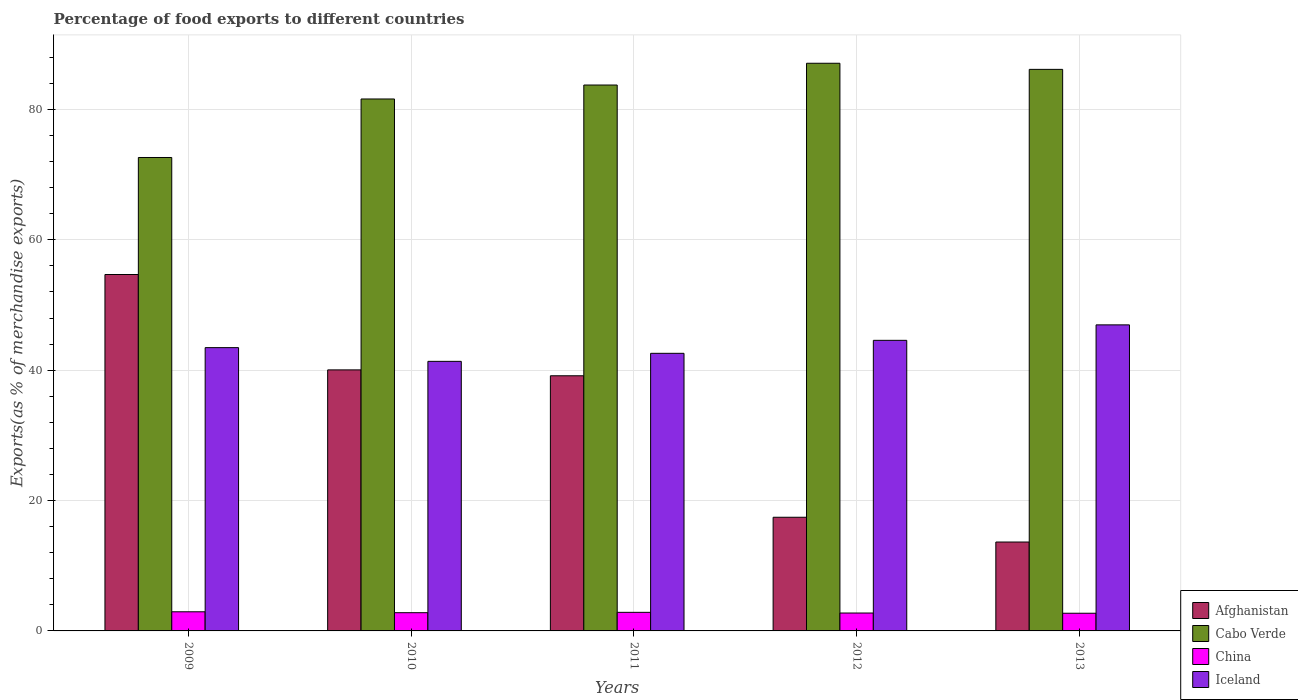How many different coloured bars are there?
Your answer should be very brief. 4. How many groups of bars are there?
Provide a short and direct response. 5. Are the number of bars per tick equal to the number of legend labels?
Ensure brevity in your answer.  Yes. How many bars are there on the 1st tick from the left?
Your answer should be compact. 4. How many bars are there on the 4th tick from the right?
Your answer should be very brief. 4. What is the label of the 3rd group of bars from the left?
Your answer should be compact. 2011. In how many cases, is the number of bars for a given year not equal to the number of legend labels?
Make the answer very short. 0. What is the percentage of exports to different countries in China in 2012?
Make the answer very short. 2.75. Across all years, what is the maximum percentage of exports to different countries in Cabo Verde?
Give a very brief answer. 87.09. Across all years, what is the minimum percentage of exports to different countries in Afghanistan?
Ensure brevity in your answer.  13.64. In which year was the percentage of exports to different countries in China minimum?
Provide a short and direct response. 2013. What is the total percentage of exports to different countries in China in the graph?
Keep it short and to the point. 14.04. What is the difference between the percentage of exports to different countries in Afghanistan in 2010 and that in 2012?
Your answer should be compact. 22.61. What is the difference between the percentage of exports to different countries in Iceland in 2012 and the percentage of exports to different countries in Afghanistan in 2013?
Offer a very short reply. 30.94. What is the average percentage of exports to different countries in Cabo Verde per year?
Your response must be concise. 82.25. In the year 2012, what is the difference between the percentage of exports to different countries in China and percentage of exports to different countries in Iceland?
Your answer should be compact. -41.83. In how many years, is the percentage of exports to different countries in Afghanistan greater than 40 %?
Offer a very short reply. 2. What is the ratio of the percentage of exports to different countries in Afghanistan in 2011 to that in 2012?
Your answer should be compact. 2.24. Is the difference between the percentage of exports to different countries in China in 2010 and 2011 greater than the difference between the percentage of exports to different countries in Iceland in 2010 and 2011?
Your answer should be very brief. Yes. What is the difference between the highest and the second highest percentage of exports to different countries in Cabo Verde?
Give a very brief answer. 0.94. What is the difference between the highest and the lowest percentage of exports to different countries in China?
Keep it short and to the point. 0.22. In how many years, is the percentage of exports to different countries in Cabo Verde greater than the average percentage of exports to different countries in Cabo Verde taken over all years?
Provide a short and direct response. 3. Is it the case that in every year, the sum of the percentage of exports to different countries in Cabo Verde and percentage of exports to different countries in Afghanistan is greater than the sum of percentage of exports to different countries in China and percentage of exports to different countries in Iceland?
Offer a terse response. Yes. What does the 3rd bar from the left in 2013 represents?
Offer a terse response. China. Is it the case that in every year, the sum of the percentage of exports to different countries in Cabo Verde and percentage of exports to different countries in Afghanistan is greater than the percentage of exports to different countries in Iceland?
Your answer should be very brief. Yes. How many bars are there?
Your answer should be very brief. 20. Are all the bars in the graph horizontal?
Ensure brevity in your answer.  No. How many years are there in the graph?
Give a very brief answer. 5. What is the difference between two consecutive major ticks on the Y-axis?
Your answer should be compact. 20. Are the values on the major ticks of Y-axis written in scientific E-notation?
Keep it short and to the point. No. Does the graph contain grids?
Keep it short and to the point. Yes. How are the legend labels stacked?
Provide a succinct answer. Vertical. What is the title of the graph?
Give a very brief answer. Percentage of food exports to different countries. What is the label or title of the X-axis?
Provide a short and direct response. Years. What is the label or title of the Y-axis?
Your answer should be compact. Exports(as % of merchandise exports). What is the Exports(as % of merchandise exports) of Afghanistan in 2009?
Offer a very short reply. 54.68. What is the Exports(as % of merchandise exports) in Cabo Verde in 2009?
Give a very brief answer. 72.63. What is the Exports(as % of merchandise exports) of China in 2009?
Your answer should be compact. 2.94. What is the Exports(as % of merchandise exports) in Iceland in 2009?
Make the answer very short. 43.46. What is the Exports(as % of merchandise exports) of Afghanistan in 2010?
Ensure brevity in your answer.  40.05. What is the Exports(as % of merchandise exports) of Cabo Verde in 2010?
Keep it short and to the point. 81.61. What is the Exports(as % of merchandise exports) of China in 2010?
Offer a very short reply. 2.8. What is the Exports(as % of merchandise exports) in Iceland in 2010?
Give a very brief answer. 41.36. What is the Exports(as % of merchandise exports) in Afghanistan in 2011?
Offer a very short reply. 39.15. What is the Exports(as % of merchandise exports) of Cabo Verde in 2011?
Your response must be concise. 83.75. What is the Exports(as % of merchandise exports) in China in 2011?
Your answer should be very brief. 2.85. What is the Exports(as % of merchandise exports) in Iceland in 2011?
Your answer should be compact. 42.59. What is the Exports(as % of merchandise exports) of Afghanistan in 2012?
Your response must be concise. 17.44. What is the Exports(as % of merchandise exports) of Cabo Verde in 2012?
Keep it short and to the point. 87.09. What is the Exports(as % of merchandise exports) in China in 2012?
Make the answer very short. 2.75. What is the Exports(as % of merchandise exports) of Iceland in 2012?
Offer a very short reply. 44.58. What is the Exports(as % of merchandise exports) in Afghanistan in 2013?
Keep it short and to the point. 13.64. What is the Exports(as % of merchandise exports) in Cabo Verde in 2013?
Provide a short and direct response. 86.15. What is the Exports(as % of merchandise exports) in China in 2013?
Make the answer very short. 2.71. What is the Exports(as % of merchandise exports) of Iceland in 2013?
Make the answer very short. 46.95. Across all years, what is the maximum Exports(as % of merchandise exports) in Afghanistan?
Your response must be concise. 54.68. Across all years, what is the maximum Exports(as % of merchandise exports) of Cabo Verde?
Your answer should be very brief. 87.09. Across all years, what is the maximum Exports(as % of merchandise exports) in China?
Your answer should be compact. 2.94. Across all years, what is the maximum Exports(as % of merchandise exports) of Iceland?
Ensure brevity in your answer.  46.95. Across all years, what is the minimum Exports(as % of merchandise exports) in Afghanistan?
Your answer should be compact. 13.64. Across all years, what is the minimum Exports(as % of merchandise exports) of Cabo Verde?
Ensure brevity in your answer.  72.63. Across all years, what is the minimum Exports(as % of merchandise exports) of China?
Keep it short and to the point. 2.71. Across all years, what is the minimum Exports(as % of merchandise exports) in Iceland?
Offer a very short reply. 41.36. What is the total Exports(as % of merchandise exports) in Afghanistan in the graph?
Make the answer very short. 164.95. What is the total Exports(as % of merchandise exports) of Cabo Verde in the graph?
Your answer should be compact. 411.24. What is the total Exports(as % of merchandise exports) in China in the graph?
Your answer should be very brief. 14.04. What is the total Exports(as % of merchandise exports) of Iceland in the graph?
Offer a very short reply. 218.94. What is the difference between the Exports(as % of merchandise exports) of Afghanistan in 2009 and that in 2010?
Offer a terse response. 14.63. What is the difference between the Exports(as % of merchandise exports) in Cabo Verde in 2009 and that in 2010?
Provide a succinct answer. -8.98. What is the difference between the Exports(as % of merchandise exports) in China in 2009 and that in 2010?
Provide a succinct answer. 0.14. What is the difference between the Exports(as % of merchandise exports) in Iceland in 2009 and that in 2010?
Provide a succinct answer. 2.1. What is the difference between the Exports(as % of merchandise exports) in Afghanistan in 2009 and that in 2011?
Offer a terse response. 15.53. What is the difference between the Exports(as % of merchandise exports) in Cabo Verde in 2009 and that in 2011?
Offer a terse response. -11.12. What is the difference between the Exports(as % of merchandise exports) in China in 2009 and that in 2011?
Ensure brevity in your answer.  0.08. What is the difference between the Exports(as % of merchandise exports) in Iceland in 2009 and that in 2011?
Your answer should be very brief. 0.87. What is the difference between the Exports(as % of merchandise exports) of Afghanistan in 2009 and that in 2012?
Offer a very short reply. 37.24. What is the difference between the Exports(as % of merchandise exports) of Cabo Verde in 2009 and that in 2012?
Provide a succinct answer. -14.46. What is the difference between the Exports(as % of merchandise exports) in China in 2009 and that in 2012?
Keep it short and to the point. 0.19. What is the difference between the Exports(as % of merchandise exports) of Iceland in 2009 and that in 2012?
Provide a short and direct response. -1.12. What is the difference between the Exports(as % of merchandise exports) of Afghanistan in 2009 and that in 2013?
Your answer should be compact. 41.04. What is the difference between the Exports(as % of merchandise exports) of Cabo Verde in 2009 and that in 2013?
Ensure brevity in your answer.  -13.52. What is the difference between the Exports(as % of merchandise exports) of China in 2009 and that in 2013?
Your response must be concise. 0.22. What is the difference between the Exports(as % of merchandise exports) of Iceland in 2009 and that in 2013?
Keep it short and to the point. -3.49. What is the difference between the Exports(as % of merchandise exports) of Afghanistan in 2010 and that in 2011?
Your response must be concise. 0.9. What is the difference between the Exports(as % of merchandise exports) in Cabo Verde in 2010 and that in 2011?
Provide a succinct answer. -2.14. What is the difference between the Exports(as % of merchandise exports) of China in 2010 and that in 2011?
Give a very brief answer. -0.06. What is the difference between the Exports(as % of merchandise exports) of Iceland in 2010 and that in 2011?
Keep it short and to the point. -1.23. What is the difference between the Exports(as % of merchandise exports) in Afghanistan in 2010 and that in 2012?
Offer a terse response. 22.61. What is the difference between the Exports(as % of merchandise exports) in Cabo Verde in 2010 and that in 2012?
Make the answer very short. -5.48. What is the difference between the Exports(as % of merchandise exports) of China in 2010 and that in 2012?
Provide a succinct answer. 0.05. What is the difference between the Exports(as % of merchandise exports) of Iceland in 2010 and that in 2012?
Keep it short and to the point. -3.22. What is the difference between the Exports(as % of merchandise exports) of Afghanistan in 2010 and that in 2013?
Make the answer very short. 26.41. What is the difference between the Exports(as % of merchandise exports) of Cabo Verde in 2010 and that in 2013?
Ensure brevity in your answer.  -4.54. What is the difference between the Exports(as % of merchandise exports) in China in 2010 and that in 2013?
Your answer should be very brief. 0.08. What is the difference between the Exports(as % of merchandise exports) in Iceland in 2010 and that in 2013?
Provide a succinct answer. -5.6. What is the difference between the Exports(as % of merchandise exports) in Afghanistan in 2011 and that in 2012?
Give a very brief answer. 21.71. What is the difference between the Exports(as % of merchandise exports) in Cabo Verde in 2011 and that in 2012?
Give a very brief answer. -3.34. What is the difference between the Exports(as % of merchandise exports) of China in 2011 and that in 2012?
Ensure brevity in your answer.  0.1. What is the difference between the Exports(as % of merchandise exports) of Iceland in 2011 and that in 2012?
Your answer should be very brief. -1.99. What is the difference between the Exports(as % of merchandise exports) in Afghanistan in 2011 and that in 2013?
Your answer should be compact. 25.51. What is the difference between the Exports(as % of merchandise exports) in Cabo Verde in 2011 and that in 2013?
Provide a short and direct response. -2.4. What is the difference between the Exports(as % of merchandise exports) in China in 2011 and that in 2013?
Keep it short and to the point. 0.14. What is the difference between the Exports(as % of merchandise exports) of Iceland in 2011 and that in 2013?
Keep it short and to the point. -4.37. What is the difference between the Exports(as % of merchandise exports) of Afghanistan in 2012 and that in 2013?
Offer a very short reply. 3.8. What is the difference between the Exports(as % of merchandise exports) of Cabo Verde in 2012 and that in 2013?
Provide a succinct answer. 0.94. What is the difference between the Exports(as % of merchandise exports) in China in 2012 and that in 2013?
Offer a terse response. 0.03. What is the difference between the Exports(as % of merchandise exports) in Iceland in 2012 and that in 2013?
Your response must be concise. -2.37. What is the difference between the Exports(as % of merchandise exports) of Afghanistan in 2009 and the Exports(as % of merchandise exports) of Cabo Verde in 2010?
Provide a short and direct response. -26.93. What is the difference between the Exports(as % of merchandise exports) of Afghanistan in 2009 and the Exports(as % of merchandise exports) of China in 2010?
Your answer should be very brief. 51.88. What is the difference between the Exports(as % of merchandise exports) of Afghanistan in 2009 and the Exports(as % of merchandise exports) of Iceland in 2010?
Provide a succinct answer. 13.32. What is the difference between the Exports(as % of merchandise exports) of Cabo Verde in 2009 and the Exports(as % of merchandise exports) of China in 2010?
Ensure brevity in your answer.  69.84. What is the difference between the Exports(as % of merchandise exports) of Cabo Verde in 2009 and the Exports(as % of merchandise exports) of Iceland in 2010?
Give a very brief answer. 31.28. What is the difference between the Exports(as % of merchandise exports) in China in 2009 and the Exports(as % of merchandise exports) in Iceland in 2010?
Provide a succinct answer. -38.42. What is the difference between the Exports(as % of merchandise exports) in Afghanistan in 2009 and the Exports(as % of merchandise exports) in Cabo Verde in 2011?
Offer a terse response. -29.07. What is the difference between the Exports(as % of merchandise exports) in Afghanistan in 2009 and the Exports(as % of merchandise exports) in China in 2011?
Your answer should be compact. 51.83. What is the difference between the Exports(as % of merchandise exports) in Afghanistan in 2009 and the Exports(as % of merchandise exports) in Iceland in 2011?
Your answer should be very brief. 12.09. What is the difference between the Exports(as % of merchandise exports) of Cabo Verde in 2009 and the Exports(as % of merchandise exports) of China in 2011?
Your response must be concise. 69.78. What is the difference between the Exports(as % of merchandise exports) of Cabo Verde in 2009 and the Exports(as % of merchandise exports) of Iceland in 2011?
Your response must be concise. 30.04. What is the difference between the Exports(as % of merchandise exports) of China in 2009 and the Exports(as % of merchandise exports) of Iceland in 2011?
Give a very brief answer. -39.65. What is the difference between the Exports(as % of merchandise exports) in Afghanistan in 2009 and the Exports(as % of merchandise exports) in Cabo Verde in 2012?
Your answer should be very brief. -32.41. What is the difference between the Exports(as % of merchandise exports) of Afghanistan in 2009 and the Exports(as % of merchandise exports) of China in 2012?
Your response must be concise. 51.93. What is the difference between the Exports(as % of merchandise exports) in Afghanistan in 2009 and the Exports(as % of merchandise exports) in Iceland in 2012?
Give a very brief answer. 10.1. What is the difference between the Exports(as % of merchandise exports) in Cabo Verde in 2009 and the Exports(as % of merchandise exports) in China in 2012?
Provide a succinct answer. 69.89. What is the difference between the Exports(as % of merchandise exports) of Cabo Verde in 2009 and the Exports(as % of merchandise exports) of Iceland in 2012?
Make the answer very short. 28.05. What is the difference between the Exports(as % of merchandise exports) in China in 2009 and the Exports(as % of merchandise exports) in Iceland in 2012?
Provide a succinct answer. -41.65. What is the difference between the Exports(as % of merchandise exports) of Afghanistan in 2009 and the Exports(as % of merchandise exports) of Cabo Verde in 2013?
Your answer should be very brief. -31.47. What is the difference between the Exports(as % of merchandise exports) of Afghanistan in 2009 and the Exports(as % of merchandise exports) of China in 2013?
Your response must be concise. 51.97. What is the difference between the Exports(as % of merchandise exports) of Afghanistan in 2009 and the Exports(as % of merchandise exports) of Iceland in 2013?
Provide a succinct answer. 7.73. What is the difference between the Exports(as % of merchandise exports) of Cabo Verde in 2009 and the Exports(as % of merchandise exports) of China in 2013?
Provide a succinct answer. 69.92. What is the difference between the Exports(as % of merchandise exports) of Cabo Verde in 2009 and the Exports(as % of merchandise exports) of Iceland in 2013?
Your response must be concise. 25.68. What is the difference between the Exports(as % of merchandise exports) of China in 2009 and the Exports(as % of merchandise exports) of Iceland in 2013?
Provide a short and direct response. -44.02. What is the difference between the Exports(as % of merchandise exports) in Afghanistan in 2010 and the Exports(as % of merchandise exports) in Cabo Verde in 2011?
Your response must be concise. -43.7. What is the difference between the Exports(as % of merchandise exports) of Afghanistan in 2010 and the Exports(as % of merchandise exports) of China in 2011?
Provide a succinct answer. 37.2. What is the difference between the Exports(as % of merchandise exports) of Afghanistan in 2010 and the Exports(as % of merchandise exports) of Iceland in 2011?
Provide a short and direct response. -2.54. What is the difference between the Exports(as % of merchandise exports) of Cabo Verde in 2010 and the Exports(as % of merchandise exports) of China in 2011?
Ensure brevity in your answer.  78.76. What is the difference between the Exports(as % of merchandise exports) in Cabo Verde in 2010 and the Exports(as % of merchandise exports) in Iceland in 2011?
Offer a very short reply. 39.02. What is the difference between the Exports(as % of merchandise exports) in China in 2010 and the Exports(as % of merchandise exports) in Iceland in 2011?
Your answer should be very brief. -39.79. What is the difference between the Exports(as % of merchandise exports) in Afghanistan in 2010 and the Exports(as % of merchandise exports) in Cabo Verde in 2012?
Make the answer very short. -47.04. What is the difference between the Exports(as % of merchandise exports) in Afghanistan in 2010 and the Exports(as % of merchandise exports) in China in 2012?
Make the answer very short. 37.3. What is the difference between the Exports(as % of merchandise exports) of Afghanistan in 2010 and the Exports(as % of merchandise exports) of Iceland in 2012?
Your answer should be compact. -4.53. What is the difference between the Exports(as % of merchandise exports) in Cabo Verde in 2010 and the Exports(as % of merchandise exports) in China in 2012?
Your response must be concise. 78.86. What is the difference between the Exports(as % of merchandise exports) of Cabo Verde in 2010 and the Exports(as % of merchandise exports) of Iceland in 2012?
Give a very brief answer. 37.03. What is the difference between the Exports(as % of merchandise exports) in China in 2010 and the Exports(as % of merchandise exports) in Iceland in 2012?
Provide a succinct answer. -41.79. What is the difference between the Exports(as % of merchandise exports) of Afghanistan in 2010 and the Exports(as % of merchandise exports) of Cabo Verde in 2013?
Keep it short and to the point. -46.11. What is the difference between the Exports(as % of merchandise exports) of Afghanistan in 2010 and the Exports(as % of merchandise exports) of China in 2013?
Provide a short and direct response. 37.33. What is the difference between the Exports(as % of merchandise exports) of Afghanistan in 2010 and the Exports(as % of merchandise exports) of Iceland in 2013?
Ensure brevity in your answer.  -6.91. What is the difference between the Exports(as % of merchandise exports) in Cabo Verde in 2010 and the Exports(as % of merchandise exports) in China in 2013?
Give a very brief answer. 78.9. What is the difference between the Exports(as % of merchandise exports) in Cabo Verde in 2010 and the Exports(as % of merchandise exports) in Iceland in 2013?
Provide a short and direct response. 34.65. What is the difference between the Exports(as % of merchandise exports) in China in 2010 and the Exports(as % of merchandise exports) in Iceland in 2013?
Your answer should be very brief. -44.16. What is the difference between the Exports(as % of merchandise exports) of Afghanistan in 2011 and the Exports(as % of merchandise exports) of Cabo Verde in 2012?
Offer a very short reply. -47.94. What is the difference between the Exports(as % of merchandise exports) of Afghanistan in 2011 and the Exports(as % of merchandise exports) of China in 2012?
Your answer should be compact. 36.4. What is the difference between the Exports(as % of merchandise exports) of Afghanistan in 2011 and the Exports(as % of merchandise exports) of Iceland in 2012?
Make the answer very short. -5.44. What is the difference between the Exports(as % of merchandise exports) in Cabo Verde in 2011 and the Exports(as % of merchandise exports) in China in 2012?
Make the answer very short. 81. What is the difference between the Exports(as % of merchandise exports) in Cabo Verde in 2011 and the Exports(as % of merchandise exports) in Iceland in 2012?
Provide a short and direct response. 39.17. What is the difference between the Exports(as % of merchandise exports) of China in 2011 and the Exports(as % of merchandise exports) of Iceland in 2012?
Offer a terse response. -41.73. What is the difference between the Exports(as % of merchandise exports) in Afghanistan in 2011 and the Exports(as % of merchandise exports) in Cabo Verde in 2013?
Make the answer very short. -47.01. What is the difference between the Exports(as % of merchandise exports) of Afghanistan in 2011 and the Exports(as % of merchandise exports) of China in 2013?
Your answer should be compact. 36.43. What is the difference between the Exports(as % of merchandise exports) in Afghanistan in 2011 and the Exports(as % of merchandise exports) in Iceland in 2013?
Ensure brevity in your answer.  -7.81. What is the difference between the Exports(as % of merchandise exports) of Cabo Verde in 2011 and the Exports(as % of merchandise exports) of China in 2013?
Ensure brevity in your answer.  81.04. What is the difference between the Exports(as % of merchandise exports) of Cabo Verde in 2011 and the Exports(as % of merchandise exports) of Iceland in 2013?
Offer a terse response. 36.8. What is the difference between the Exports(as % of merchandise exports) of China in 2011 and the Exports(as % of merchandise exports) of Iceland in 2013?
Offer a terse response. -44.1. What is the difference between the Exports(as % of merchandise exports) in Afghanistan in 2012 and the Exports(as % of merchandise exports) in Cabo Verde in 2013?
Your answer should be compact. -68.72. What is the difference between the Exports(as % of merchandise exports) of Afghanistan in 2012 and the Exports(as % of merchandise exports) of China in 2013?
Give a very brief answer. 14.72. What is the difference between the Exports(as % of merchandise exports) of Afghanistan in 2012 and the Exports(as % of merchandise exports) of Iceland in 2013?
Your response must be concise. -29.52. What is the difference between the Exports(as % of merchandise exports) in Cabo Verde in 2012 and the Exports(as % of merchandise exports) in China in 2013?
Provide a succinct answer. 84.38. What is the difference between the Exports(as % of merchandise exports) in Cabo Verde in 2012 and the Exports(as % of merchandise exports) in Iceland in 2013?
Give a very brief answer. 40.14. What is the difference between the Exports(as % of merchandise exports) of China in 2012 and the Exports(as % of merchandise exports) of Iceland in 2013?
Provide a succinct answer. -44.21. What is the average Exports(as % of merchandise exports) of Afghanistan per year?
Ensure brevity in your answer.  32.99. What is the average Exports(as % of merchandise exports) in Cabo Verde per year?
Offer a terse response. 82.25. What is the average Exports(as % of merchandise exports) of China per year?
Keep it short and to the point. 2.81. What is the average Exports(as % of merchandise exports) in Iceland per year?
Provide a succinct answer. 43.79. In the year 2009, what is the difference between the Exports(as % of merchandise exports) of Afghanistan and Exports(as % of merchandise exports) of Cabo Verde?
Provide a succinct answer. -17.95. In the year 2009, what is the difference between the Exports(as % of merchandise exports) of Afghanistan and Exports(as % of merchandise exports) of China?
Provide a short and direct response. 51.74. In the year 2009, what is the difference between the Exports(as % of merchandise exports) in Afghanistan and Exports(as % of merchandise exports) in Iceland?
Provide a short and direct response. 11.22. In the year 2009, what is the difference between the Exports(as % of merchandise exports) of Cabo Verde and Exports(as % of merchandise exports) of China?
Provide a short and direct response. 69.7. In the year 2009, what is the difference between the Exports(as % of merchandise exports) in Cabo Verde and Exports(as % of merchandise exports) in Iceland?
Offer a terse response. 29.17. In the year 2009, what is the difference between the Exports(as % of merchandise exports) of China and Exports(as % of merchandise exports) of Iceland?
Give a very brief answer. -40.53. In the year 2010, what is the difference between the Exports(as % of merchandise exports) in Afghanistan and Exports(as % of merchandise exports) in Cabo Verde?
Offer a very short reply. -41.56. In the year 2010, what is the difference between the Exports(as % of merchandise exports) in Afghanistan and Exports(as % of merchandise exports) in China?
Give a very brief answer. 37.25. In the year 2010, what is the difference between the Exports(as % of merchandise exports) of Afghanistan and Exports(as % of merchandise exports) of Iceland?
Your answer should be compact. -1.31. In the year 2010, what is the difference between the Exports(as % of merchandise exports) in Cabo Verde and Exports(as % of merchandise exports) in China?
Provide a short and direct response. 78.81. In the year 2010, what is the difference between the Exports(as % of merchandise exports) in Cabo Verde and Exports(as % of merchandise exports) in Iceland?
Give a very brief answer. 40.25. In the year 2010, what is the difference between the Exports(as % of merchandise exports) of China and Exports(as % of merchandise exports) of Iceland?
Make the answer very short. -38.56. In the year 2011, what is the difference between the Exports(as % of merchandise exports) in Afghanistan and Exports(as % of merchandise exports) in Cabo Verde?
Make the answer very short. -44.6. In the year 2011, what is the difference between the Exports(as % of merchandise exports) of Afghanistan and Exports(as % of merchandise exports) of China?
Provide a short and direct response. 36.29. In the year 2011, what is the difference between the Exports(as % of merchandise exports) in Afghanistan and Exports(as % of merchandise exports) in Iceland?
Give a very brief answer. -3.44. In the year 2011, what is the difference between the Exports(as % of merchandise exports) of Cabo Verde and Exports(as % of merchandise exports) of China?
Give a very brief answer. 80.9. In the year 2011, what is the difference between the Exports(as % of merchandise exports) in Cabo Verde and Exports(as % of merchandise exports) in Iceland?
Provide a short and direct response. 41.16. In the year 2011, what is the difference between the Exports(as % of merchandise exports) in China and Exports(as % of merchandise exports) in Iceland?
Your answer should be very brief. -39.74. In the year 2012, what is the difference between the Exports(as % of merchandise exports) in Afghanistan and Exports(as % of merchandise exports) in Cabo Verde?
Provide a short and direct response. -69.65. In the year 2012, what is the difference between the Exports(as % of merchandise exports) of Afghanistan and Exports(as % of merchandise exports) of China?
Provide a short and direct response. 14.69. In the year 2012, what is the difference between the Exports(as % of merchandise exports) in Afghanistan and Exports(as % of merchandise exports) in Iceland?
Your answer should be compact. -27.14. In the year 2012, what is the difference between the Exports(as % of merchandise exports) in Cabo Verde and Exports(as % of merchandise exports) in China?
Offer a very short reply. 84.34. In the year 2012, what is the difference between the Exports(as % of merchandise exports) of Cabo Verde and Exports(as % of merchandise exports) of Iceland?
Your response must be concise. 42.51. In the year 2012, what is the difference between the Exports(as % of merchandise exports) of China and Exports(as % of merchandise exports) of Iceland?
Keep it short and to the point. -41.83. In the year 2013, what is the difference between the Exports(as % of merchandise exports) of Afghanistan and Exports(as % of merchandise exports) of Cabo Verde?
Offer a very short reply. -72.51. In the year 2013, what is the difference between the Exports(as % of merchandise exports) of Afghanistan and Exports(as % of merchandise exports) of China?
Offer a very short reply. 10.93. In the year 2013, what is the difference between the Exports(as % of merchandise exports) in Afghanistan and Exports(as % of merchandise exports) in Iceland?
Make the answer very short. -33.32. In the year 2013, what is the difference between the Exports(as % of merchandise exports) in Cabo Verde and Exports(as % of merchandise exports) in China?
Provide a succinct answer. 83.44. In the year 2013, what is the difference between the Exports(as % of merchandise exports) of Cabo Verde and Exports(as % of merchandise exports) of Iceland?
Provide a short and direct response. 39.2. In the year 2013, what is the difference between the Exports(as % of merchandise exports) in China and Exports(as % of merchandise exports) in Iceland?
Keep it short and to the point. -44.24. What is the ratio of the Exports(as % of merchandise exports) in Afghanistan in 2009 to that in 2010?
Your response must be concise. 1.37. What is the ratio of the Exports(as % of merchandise exports) of Cabo Verde in 2009 to that in 2010?
Your response must be concise. 0.89. What is the ratio of the Exports(as % of merchandise exports) of China in 2009 to that in 2010?
Your response must be concise. 1.05. What is the ratio of the Exports(as % of merchandise exports) in Iceland in 2009 to that in 2010?
Your answer should be compact. 1.05. What is the ratio of the Exports(as % of merchandise exports) of Afghanistan in 2009 to that in 2011?
Keep it short and to the point. 1.4. What is the ratio of the Exports(as % of merchandise exports) in Cabo Verde in 2009 to that in 2011?
Your answer should be very brief. 0.87. What is the ratio of the Exports(as % of merchandise exports) of China in 2009 to that in 2011?
Your response must be concise. 1.03. What is the ratio of the Exports(as % of merchandise exports) of Iceland in 2009 to that in 2011?
Your answer should be compact. 1.02. What is the ratio of the Exports(as % of merchandise exports) in Afghanistan in 2009 to that in 2012?
Your answer should be very brief. 3.14. What is the ratio of the Exports(as % of merchandise exports) in Cabo Verde in 2009 to that in 2012?
Provide a short and direct response. 0.83. What is the ratio of the Exports(as % of merchandise exports) of China in 2009 to that in 2012?
Provide a succinct answer. 1.07. What is the ratio of the Exports(as % of merchandise exports) of Iceland in 2009 to that in 2012?
Your response must be concise. 0.97. What is the ratio of the Exports(as % of merchandise exports) in Afghanistan in 2009 to that in 2013?
Make the answer very short. 4.01. What is the ratio of the Exports(as % of merchandise exports) in Cabo Verde in 2009 to that in 2013?
Provide a succinct answer. 0.84. What is the ratio of the Exports(as % of merchandise exports) in China in 2009 to that in 2013?
Your answer should be very brief. 1.08. What is the ratio of the Exports(as % of merchandise exports) in Iceland in 2009 to that in 2013?
Keep it short and to the point. 0.93. What is the ratio of the Exports(as % of merchandise exports) of Afghanistan in 2010 to that in 2011?
Ensure brevity in your answer.  1.02. What is the ratio of the Exports(as % of merchandise exports) in Cabo Verde in 2010 to that in 2011?
Keep it short and to the point. 0.97. What is the ratio of the Exports(as % of merchandise exports) in China in 2010 to that in 2011?
Offer a terse response. 0.98. What is the ratio of the Exports(as % of merchandise exports) of Iceland in 2010 to that in 2011?
Offer a terse response. 0.97. What is the ratio of the Exports(as % of merchandise exports) of Afghanistan in 2010 to that in 2012?
Your response must be concise. 2.3. What is the ratio of the Exports(as % of merchandise exports) of Cabo Verde in 2010 to that in 2012?
Provide a short and direct response. 0.94. What is the ratio of the Exports(as % of merchandise exports) in China in 2010 to that in 2012?
Offer a terse response. 1.02. What is the ratio of the Exports(as % of merchandise exports) of Iceland in 2010 to that in 2012?
Your answer should be very brief. 0.93. What is the ratio of the Exports(as % of merchandise exports) of Afghanistan in 2010 to that in 2013?
Provide a short and direct response. 2.94. What is the ratio of the Exports(as % of merchandise exports) of Cabo Verde in 2010 to that in 2013?
Ensure brevity in your answer.  0.95. What is the ratio of the Exports(as % of merchandise exports) in China in 2010 to that in 2013?
Give a very brief answer. 1.03. What is the ratio of the Exports(as % of merchandise exports) of Iceland in 2010 to that in 2013?
Make the answer very short. 0.88. What is the ratio of the Exports(as % of merchandise exports) of Afghanistan in 2011 to that in 2012?
Provide a short and direct response. 2.24. What is the ratio of the Exports(as % of merchandise exports) in Cabo Verde in 2011 to that in 2012?
Provide a short and direct response. 0.96. What is the ratio of the Exports(as % of merchandise exports) of China in 2011 to that in 2012?
Offer a very short reply. 1.04. What is the ratio of the Exports(as % of merchandise exports) in Iceland in 2011 to that in 2012?
Your response must be concise. 0.96. What is the ratio of the Exports(as % of merchandise exports) in Afghanistan in 2011 to that in 2013?
Offer a very short reply. 2.87. What is the ratio of the Exports(as % of merchandise exports) of Cabo Verde in 2011 to that in 2013?
Give a very brief answer. 0.97. What is the ratio of the Exports(as % of merchandise exports) in China in 2011 to that in 2013?
Provide a succinct answer. 1.05. What is the ratio of the Exports(as % of merchandise exports) in Iceland in 2011 to that in 2013?
Your answer should be compact. 0.91. What is the ratio of the Exports(as % of merchandise exports) in Afghanistan in 2012 to that in 2013?
Keep it short and to the point. 1.28. What is the ratio of the Exports(as % of merchandise exports) of Cabo Verde in 2012 to that in 2013?
Give a very brief answer. 1.01. What is the ratio of the Exports(as % of merchandise exports) in China in 2012 to that in 2013?
Provide a succinct answer. 1.01. What is the ratio of the Exports(as % of merchandise exports) of Iceland in 2012 to that in 2013?
Your response must be concise. 0.95. What is the difference between the highest and the second highest Exports(as % of merchandise exports) in Afghanistan?
Your answer should be very brief. 14.63. What is the difference between the highest and the second highest Exports(as % of merchandise exports) in Cabo Verde?
Give a very brief answer. 0.94. What is the difference between the highest and the second highest Exports(as % of merchandise exports) in China?
Give a very brief answer. 0.08. What is the difference between the highest and the second highest Exports(as % of merchandise exports) in Iceland?
Your answer should be compact. 2.37. What is the difference between the highest and the lowest Exports(as % of merchandise exports) in Afghanistan?
Offer a terse response. 41.04. What is the difference between the highest and the lowest Exports(as % of merchandise exports) in Cabo Verde?
Give a very brief answer. 14.46. What is the difference between the highest and the lowest Exports(as % of merchandise exports) of China?
Your answer should be compact. 0.22. What is the difference between the highest and the lowest Exports(as % of merchandise exports) in Iceland?
Ensure brevity in your answer.  5.6. 